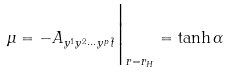Convert formula to latex. <formula><loc_0><loc_0><loc_500><loc_500>\mu = - A _ { y ^ { 1 } y ^ { 2 } \cdots y ^ { p } \tilde { t } } \Big | _ { r = r _ { H } } = \tanh \alpha</formula> 